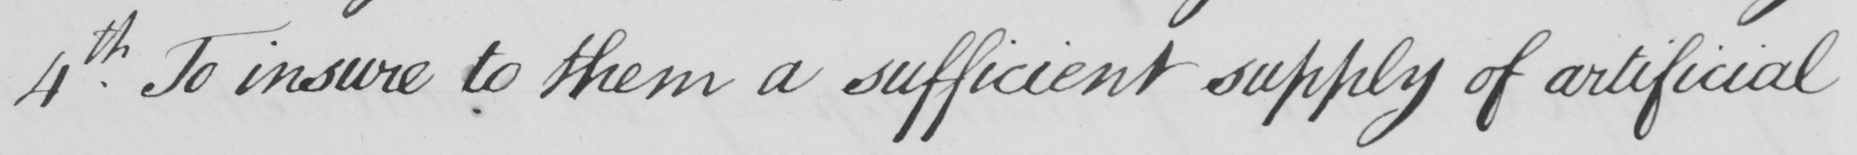Transcribe the text shown in this historical manuscript line. 4th To insure to them a sufficient supply of artificial 